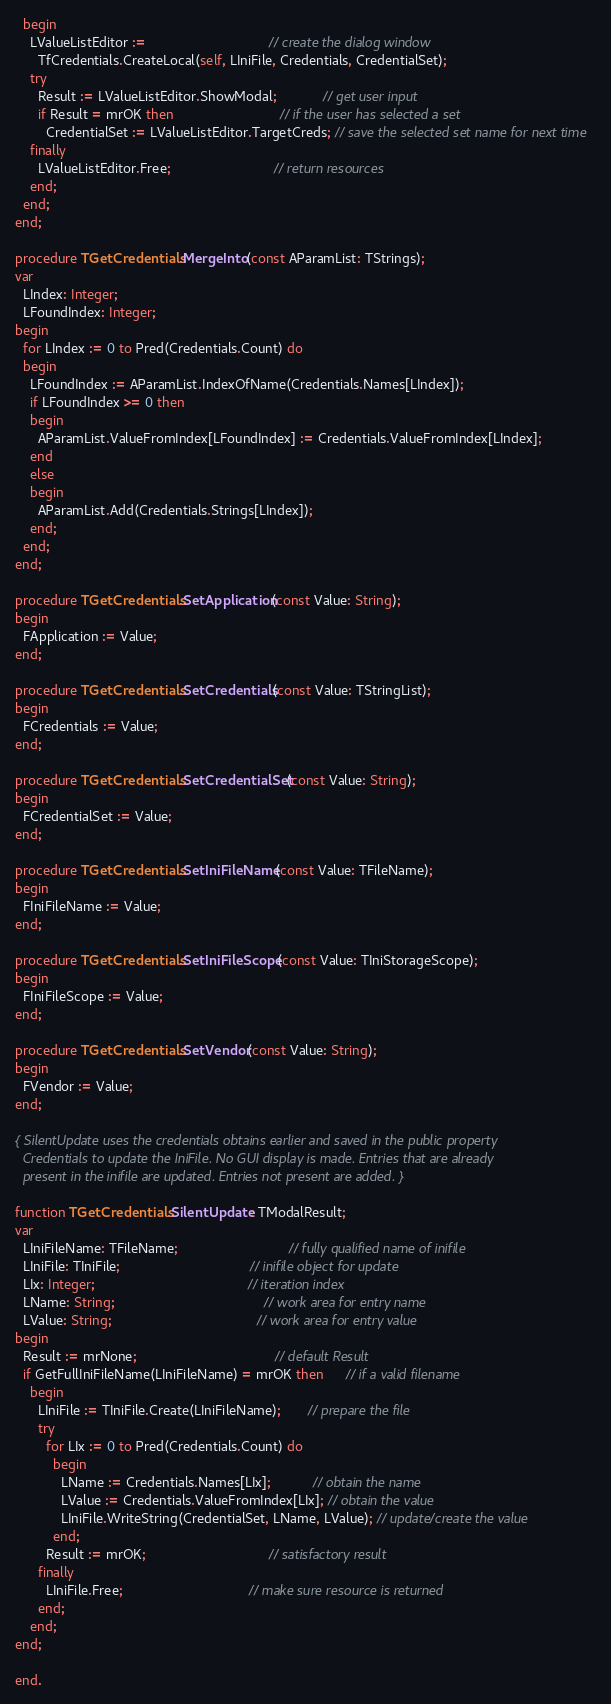Convert code to text. <code><loc_0><loc_0><loc_500><loc_500><_Pascal_>  begin
    LValueListEditor :=                                // create the dialog window
      TfCredentials.CreateLocal(self, LIniFile, Credentials, CredentialSet);
    try
      Result := LValueListEditor.ShowModal;            // get user input
      if Result = mrOK then                            // if the user has selected a set
        CredentialSet := LValueListEditor.TargetCreds; // save the selected set name for next time
    finally
      LValueListEditor.Free;                           // return resources
    end;
  end;
end;

procedure TGetCredentials.MergeInto(const AParamList: TStrings);
var
  LIndex: Integer;
  LFoundIndex: Integer;
begin
  for LIndex := 0 to Pred(Credentials.Count) do
  begin
    LFoundIndex := AParamList.IndexOfName(Credentials.Names[LIndex]);
    if LFoundIndex >= 0 then
    begin
      AParamList.ValueFromIndex[LFoundIndex] := Credentials.ValueFromIndex[LIndex];
    end
    else
    begin
      AParamList.Add(Credentials.Strings[LIndex]);
    end;
  end;
end;

procedure TGetCredentials.SetApplication(const Value: String);
begin
  FApplication := Value;
end;

procedure TGetCredentials.SetCredentials(const Value: TStringList);
begin
  FCredentials := Value;
end;

procedure TGetCredentials.SetCredentialSet(const Value: String);
begin
  FCredentialSet := Value;
end;

procedure TGetCredentials.SetIniFileName(const Value: TFileName);
begin
  FIniFileName := Value;
end;

procedure TGetCredentials.SetIniFileScope(const Value: TIniStorageScope);
begin
  FIniFileScope := Value;
end;

procedure TGetCredentials.SetVendor(const Value: String);
begin
  FVendor := Value;
end;

{ SilentUpdate uses the credentials obtains earlier and saved in the public property
  Credentials to update the IniFile. No GUI display is made. Entries that are already
  present in the inifile are updated. Entries not present are added. }

function TGetCredentials.SilentUpdate: TModalResult;
var
  LIniFileName: TFileName;                             // fully qualified name of inifile
  LIniFile: TIniFile;                                  // inifile object for update
  LIx: Integer;                                        // iteration index
  LName: String;                                       // work area for entry name
  LValue: String;                                      // work area for entry value
begin
  Result := mrNone;                                    // default Result
  if GetFullIniFileName(LIniFileName) = mrOK then      // if a valid filename
    begin
      LIniFile := TIniFile.Create(LIniFileName);       // prepare the file
      try
        for LIx := 0 to Pred(Credentials.Count) do
          begin
            LName := Credentials.Names[LIx];           // obtain the name
            LValue := Credentials.ValueFromIndex[LIx]; // obtain the value
            LIniFile.WriteString(CredentialSet, LName, LValue); // update/create the value
          end;
        Result := mrOK;                                // satisfactory result
      finally
        LIniFile.Free;                                 // make sure resource is returned
      end;
    end;
end;

end.
</code> 